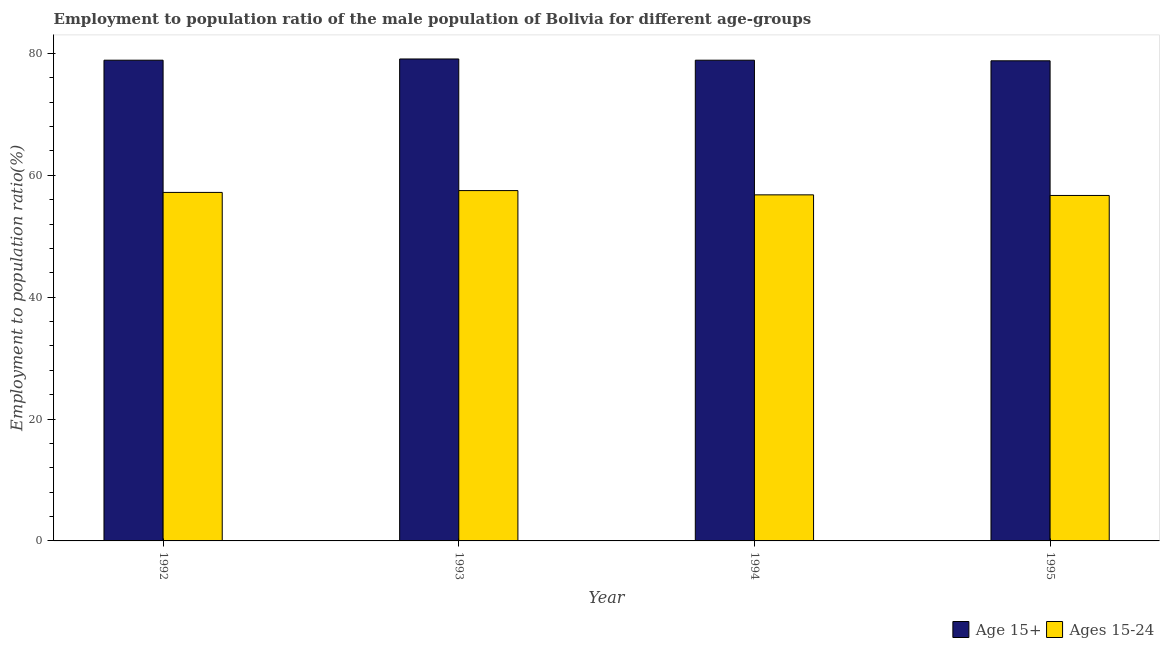How many groups of bars are there?
Keep it short and to the point. 4. Are the number of bars on each tick of the X-axis equal?
Provide a short and direct response. Yes. How many bars are there on the 4th tick from the right?
Provide a succinct answer. 2. What is the label of the 2nd group of bars from the left?
Your response must be concise. 1993. In how many cases, is the number of bars for a given year not equal to the number of legend labels?
Provide a short and direct response. 0. What is the employment to population ratio(age 15+) in 1993?
Offer a very short reply. 79.1. Across all years, what is the maximum employment to population ratio(age 15+)?
Provide a succinct answer. 79.1. Across all years, what is the minimum employment to population ratio(age 15+)?
Your response must be concise. 78.8. What is the total employment to population ratio(age 15+) in the graph?
Give a very brief answer. 315.7. What is the difference between the employment to population ratio(age 15-24) in 1993 and that in 1994?
Offer a terse response. 0.7. What is the difference between the employment to population ratio(age 15-24) in 1995 and the employment to population ratio(age 15+) in 1993?
Give a very brief answer. -0.8. What is the average employment to population ratio(age 15-24) per year?
Provide a succinct answer. 57.05. In the year 1994, what is the difference between the employment to population ratio(age 15+) and employment to population ratio(age 15-24)?
Keep it short and to the point. 0. What is the ratio of the employment to population ratio(age 15-24) in 1992 to that in 1995?
Give a very brief answer. 1.01. What is the difference between the highest and the second highest employment to population ratio(age 15-24)?
Your answer should be very brief. 0.3. What is the difference between the highest and the lowest employment to population ratio(age 15-24)?
Provide a short and direct response. 0.8. In how many years, is the employment to population ratio(age 15-24) greater than the average employment to population ratio(age 15-24) taken over all years?
Keep it short and to the point. 2. Is the sum of the employment to population ratio(age 15+) in 1993 and 1995 greater than the maximum employment to population ratio(age 15-24) across all years?
Your answer should be very brief. Yes. What does the 1st bar from the left in 1992 represents?
Provide a succinct answer. Age 15+. What does the 1st bar from the right in 1992 represents?
Keep it short and to the point. Ages 15-24. Are the values on the major ticks of Y-axis written in scientific E-notation?
Give a very brief answer. No. Where does the legend appear in the graph?
Keep it short and to the point. Bottom right. How many legend labels are there?
Give a very brief answer. 2. How are the legend labels stacked?
Provide a succinct answer. Horizontal. What is the title of the graph?
Provide a succinct answer. Employment to population ratio of the male population of Bolivia for different age-groups. What is the label or title of the X-axis?
Give a very brief answer. Year. What is the label or title of the Y-axis?
Provide a succinct answer. Employment to population ratio(%). What is the Employment to population ratio(%) in Age 15+ in 1992?
Your answer should be compact. 78.9. What is the Employment to population ratio(%) of Ages 15-24 in 1992?
Keep it short and to the point. 57.2. What is the Employment to population ratio(%) of Age 15+ in 1993?
Offer a very short reply. 79.1. What is the Employment to population ratio(%) in Ages 15-24 in 1993?
Your answer should be very brief. 57.5. What is the Employment to population ratio(%) of Age 15+ in 1994?
Your response must be concise. 78.9. What is the Employment to population ratio(%) of Ages 15-24 in 1994?
Your answer should be compact. 56.8. What is the Employment to population ratio(%) of Age 15+ in 1995?
Keep it short and to the point. 78.8. What is the Employment to population ratio(%) in Ages 15-24 in 1995?
Give a very brief answer. 56.7. Across all years, what is the maximum Employment to population ratio(%) of Age 15+?
Your answer should be compact. 79.1. Across all years, what is the maximum Employment to population ratio(%) of Ages 15-24?
Your response must be concise. 57.5. Across all years, what is the minimum Employment to population ratio(%) of Age 15+?
Offer a terse response. 78.8. Across all years, what is the minimum Employment to population ratio(%) of Ages 15-24?
Provide a succinct answer. 56.7. What is the total Employment to population ratio(%) in Age 15+ in the graph?
Provide a succinct answer. 315.7. What is the total Employment to population ratio(%) in Ages 15-24 in the graph?
Provide a short and direct response. 228.2. What is the difference between the Employment to population ratio(%) in Age 15+ in 1992 and that in 1993?
Provide a succinct answer. -0.2. What is the difference between the Employment to population ratio(%) in Age 15+ in 1992 and that in 1994?
Your answer should be very brief. 0. What is the difference between the Employment to population ratio(%) in Ages 15-24 in 1992 and that in 1994?
Give a very brief answer. 0.4. What is the difference between the Employment to population ratio(%) of Ages 15-24 in 1992 and that in 1995?
Your answer should be compact. 0.5. What is the difference between the Employment to population ratio(%) of Age 15+ in 1993 and that in 1994?
Your answer should be compact. 0.2. What is the difference between the Employment to population ratio(%) of Ages 15-24 in 1993 and that in 1994?
Provide a short and direct response. 0.7. What is the difference between the Employment to population ratio(%) of Age 15+ in 1993 and that in 1995?
Provide a short and direct response. 0.3. What is the difference between the Employment to population ratio(%) in Ages 15-24 in 1993 and that in 1995?
Offer a very short reply. 0.8. What is the difference between the Employment to population ratio(%) of Age 15+ in 1992 and the Employment to population ratio(%) of Ages 15-24 in 1993?
Give a very brief answer. 21.4. What is the difference between the Employment to population ratio(%) of Age 15+ in 1992 and the Employment to population ratio(%) of Ages 15-24 in 1994?
Your answer should be compact. 22.1. What is the difference between the Employment to population ratio(%) in Age 15+ in 1993 and the Employment to population ratio(%) in Ages 15-24 in 1994?
Make the answer very short. 22.3. What is the difference between the Employment to population ratio(%) of Age 15+ in 1993 and the Employment to population ratio(%) of Ages 15-24 in 1995?
Offer a terse response. 22.4. What is the difference between the Employment to population ratio(%) of Age 15+ in 1994 and the Employment to population ratio(%) of Ages 15-24 in 1995?
Provide a succinct answer. 22.2. What is the average Employment to population ratio(%) in Age 15+ per year?
Keep it short and to the point. 78.92. What is the average Employment to population ratio(%) in Ages 15-24 per year?
Your answer should be very brief. 57.05. In the year 1992, what is the difference between the Employment to population ratio(%) in Age 15+ and Employment to population ratio(%) in Ages 15-24?
Make the answer very short. 21.7. In the year 1993, what is the difference between the Employment to population ratio(%) in Age 15+ and Employment to population ratio(%) in Ages 15-24?
Ensure brevity in your answer.  21.6. In the year 1994, what is the difference between the Employment to population ratio(%) in Age 15+ and Employment to population ratio(%) in Ages 15-24?
Offer a terse response. 22.1. In the year 1995, what is the difference between the Employment to population ratio(%) in Age 15+ and Employment to population ratio(%) in Ages 15-24?
Your response must be concise. 22.1. What is the ratio of the Employment to population ratio(%) in Age 15+ in 1992 to that in 1993?
Give a very brief answer. 1. What is the ratio of the Employment to population ratio(%) in Ages 15-24 in 1992 to that in 1993?
Your response must be concise. 0.99. What is the ratio of the Employment to population ratio(%) in Ages 15-24 in 1992 to that in 1995?
Ensure brevity in your answer.  1.01. What is the ratio of the Employment to population ratio(%) in Age 15+ in 1993 to that in 1994?
Ensure brevity in your answer.  1. What is the ratio of the Employment to population ratio(%) in Ages 15-24 in 1993 to that in 1994?
Ensure brevity in your answer.  1.01. What is the ratio of the Employment to population ratio(%) in Ages 15-24 in 1993 to that in 1995?
Your answer should be compact. 1.01. What is the difference between the highest and the second highest Employment to population ratio(%) of Age 15+?
Give a very brief answer. 0.2. What is the difference between the highest and the lowest Employment to population ratio(%) in Ages 15-24?
Provide a succinct answer. 0.8. 